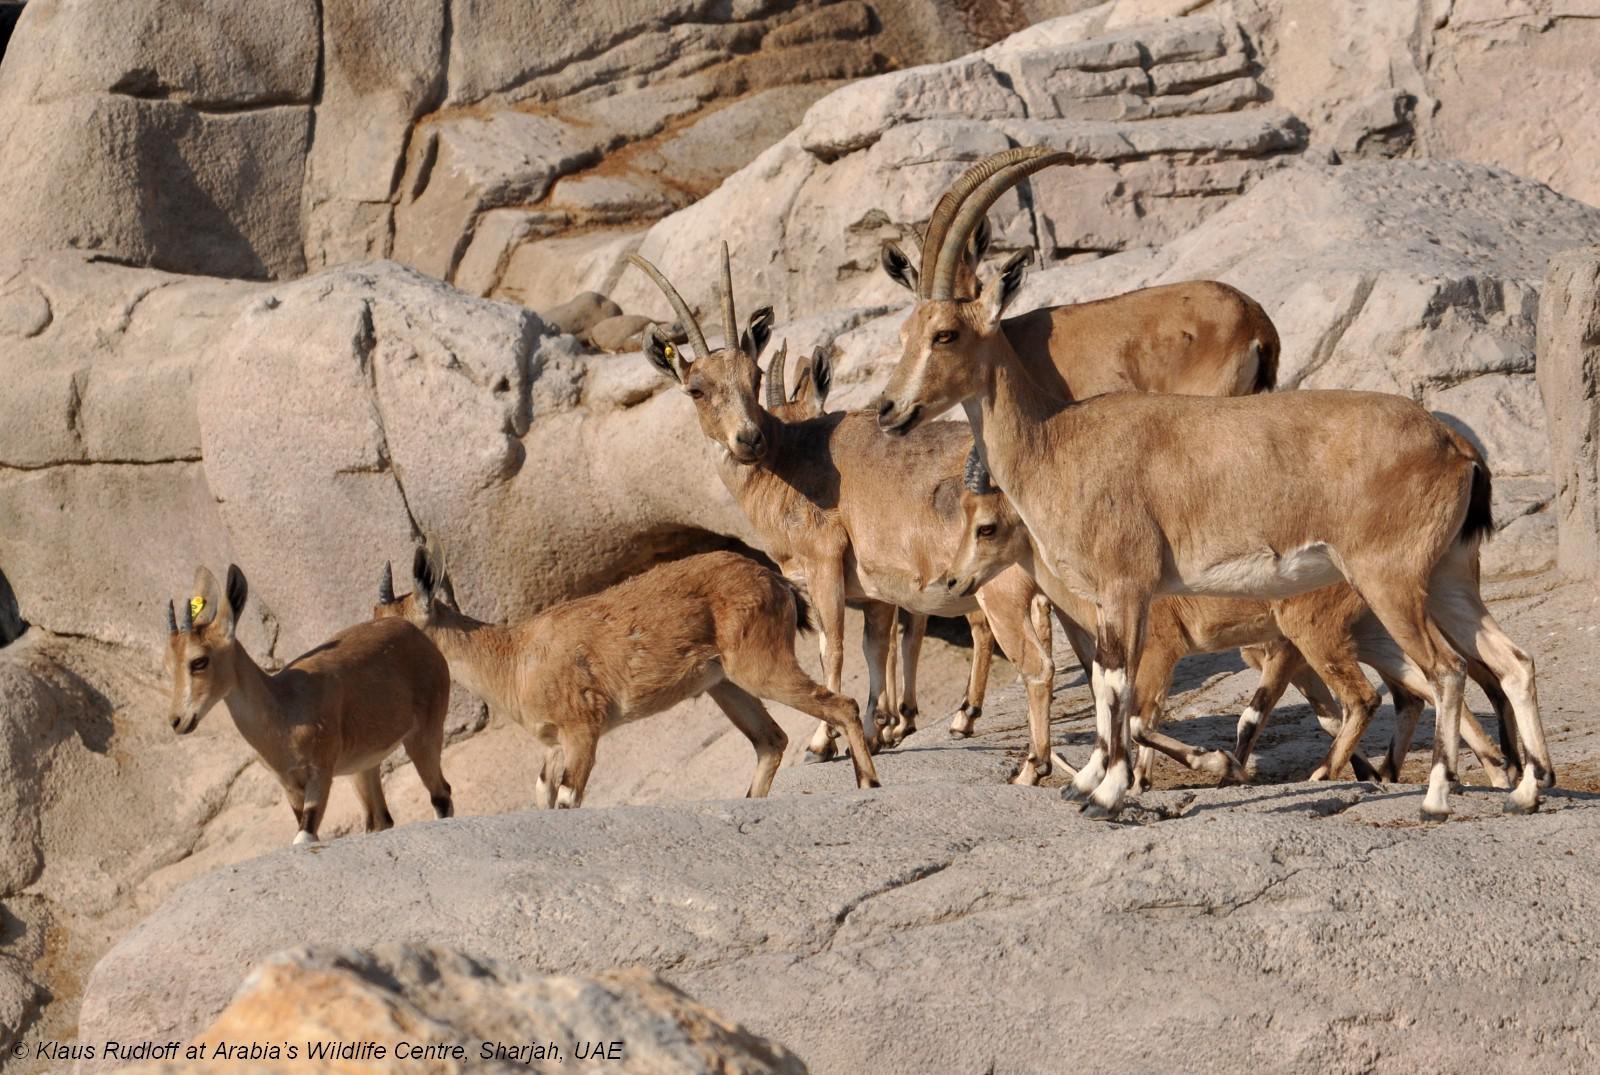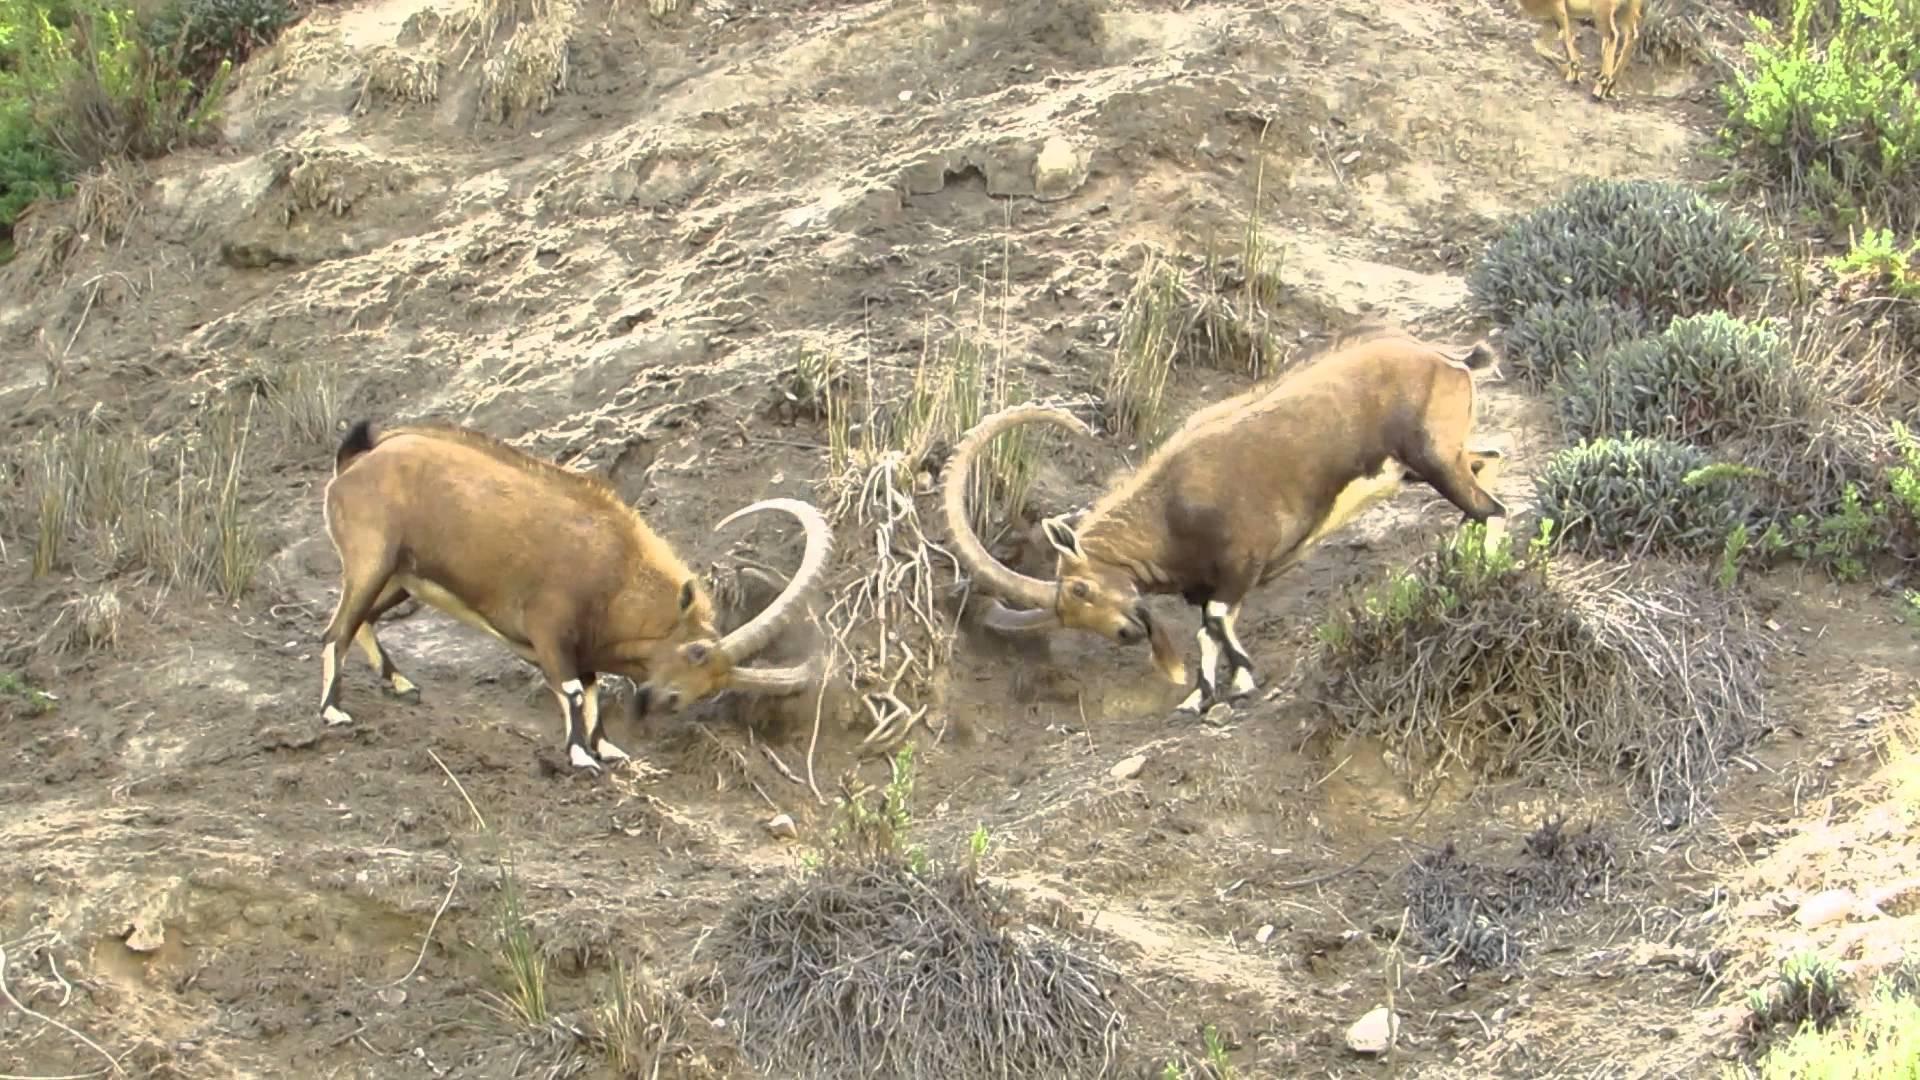The first image is the image on the left, the second image is the image on the right. Analyze the images presented: Is the assertion "In one of the images there is one man holding a rifle and posing in front of a large ram." valid? Answer yes or no. No. The first image is the image on the left, the second image is the image on the right. For the images shown, is this caption "There are two hunters with two horned animals." true? Answer yes or no. No. 